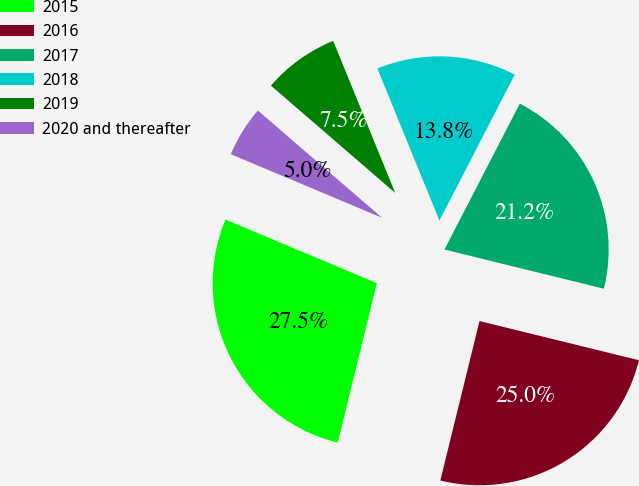<chart> <loc_0><loc_0><loc_500><loc_500><pie_chart><fcel>2015<fcel>2016<fcel>2017<fcel>2018<fcel>2019<fcel>2020 and thereafter<nl><fcel>27.5%<fcel>25.0%<fcel>21.25%<fcel>13.75%<fcel>7.5%<fcel>5.0%<nl></chart> 